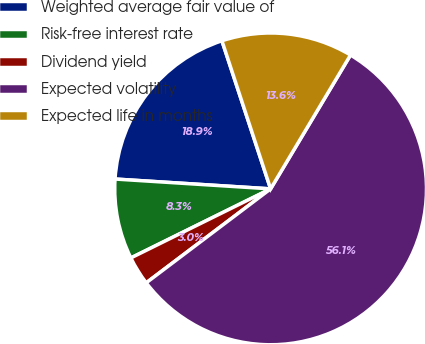<chart> <loc_0><loc_0><loc_500><loc_500><pie_chart><fcel>Weighted average fair value of<fcel>Risk-free interest rate<fcel>Dividend yield<fcel>Expected volatility<fcel>Expected life in months<nl><fcel>18.94%<fcel>8.31%<fcel>2.99%<fcel>56.14%<fcel>13.62%<nl></chart> 